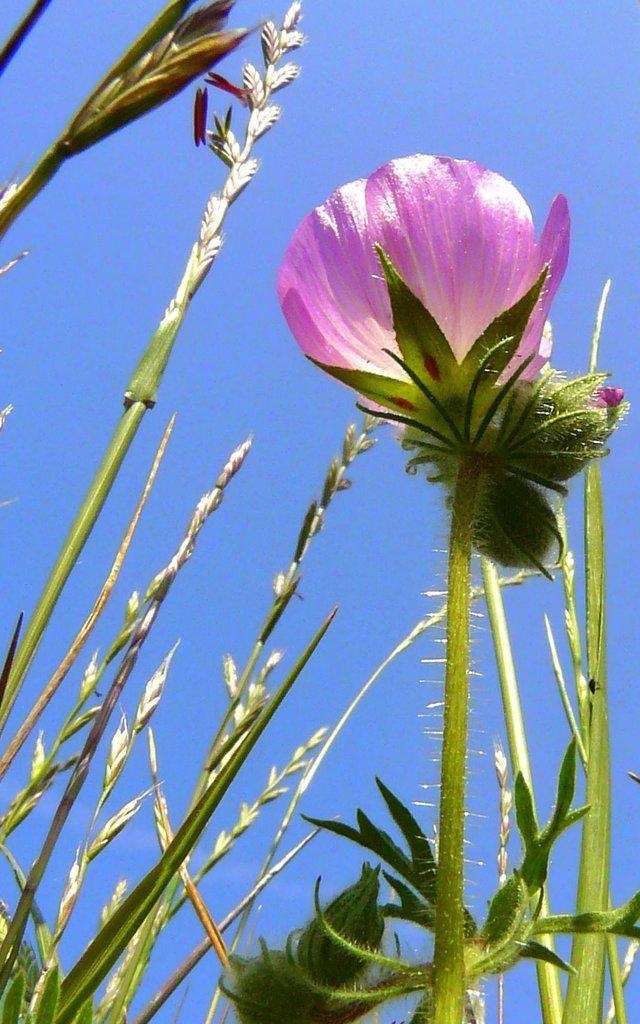Describe this image in one or two sentences. In this image, we can see a flower with stem and leaves. Here we can see few plants. Background we can see the sky. 